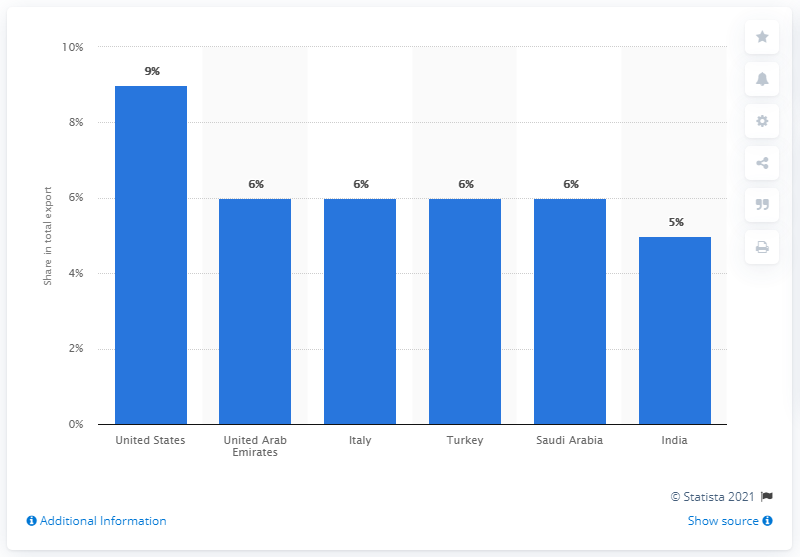Draw attention to some important aspects in this diagram. In 2019, approximately 9% of Egypt's total exports were sourced from the United States. In 2019, Egypt's most important export partner was the United States. 